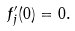<formula> <loc_0><loc_0><loc_500><loc_500>f ^ { \prime } _ { j } ( 0 ) = 0 .</formula> 